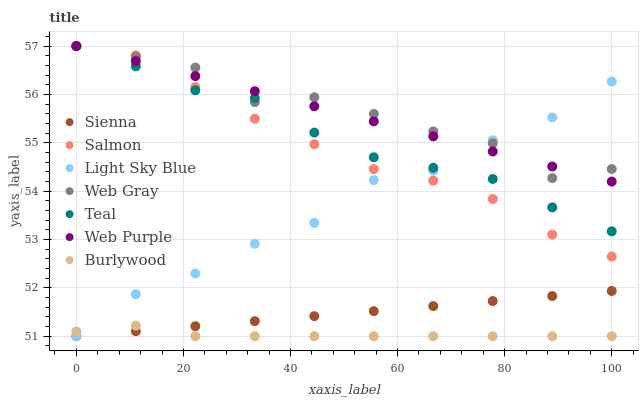Does Burlywood have the minimum area under the curve?
Answer yes or no. Yes. Does Web Gray have the maximum area under the curve?
Answer yes or no. Yes. Does Salmon have the minimum area under the curve?
Answer yes or no. No. Does Salmon have the maximum area under the curve?
Answer yes or no. No. Is Sienna the smoothest?
Answer yes or no. Yes. Is Web Gray the roughest?
Answer yes or no. Yes. Is Burlywood the smoothest?
Answer yes or no. No. Is Burlywood the roughest?
Answer yes or no. No. Does Burlywood have the lowest value?
Answer yes or no. Yes. Does Salmon have the lowest value?
Answer yes or no. No. Does Teal have the highest value?
Answer yes or no. Yes. Does Burlywood have the highest value?
Answer yes or no. No. Is Sienna less than Salmon?
Answer yes or no. Yes. Is Teal greater than Burlywood?
Answer yes or no. Yes. Does Web Gray intersect Light Sky Blue?
Answer yes or no. Yes. Is Web Gray less than Light Sky Blue?
Answer yes or no. No. Is Web Gray greater than Light Sky Blue?
Answer yes or no. No. Does Sienna intersect Salmon?
Answer yes or no. No. 